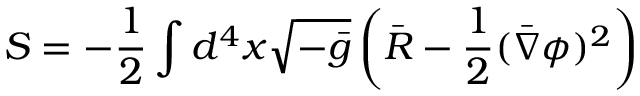Convert formula to latex. <formula><loc_0><loc_0><loc_500><loc_500>S = - \frac { 1 } { 2 } \int d ^ { 4 } x \sqrt { - \bar { g } } \left ( \bar { R } - \frac { 1 } { 2 } ( \bar { \nabla } \phi ) ^ { 2 } \right )</formula> 